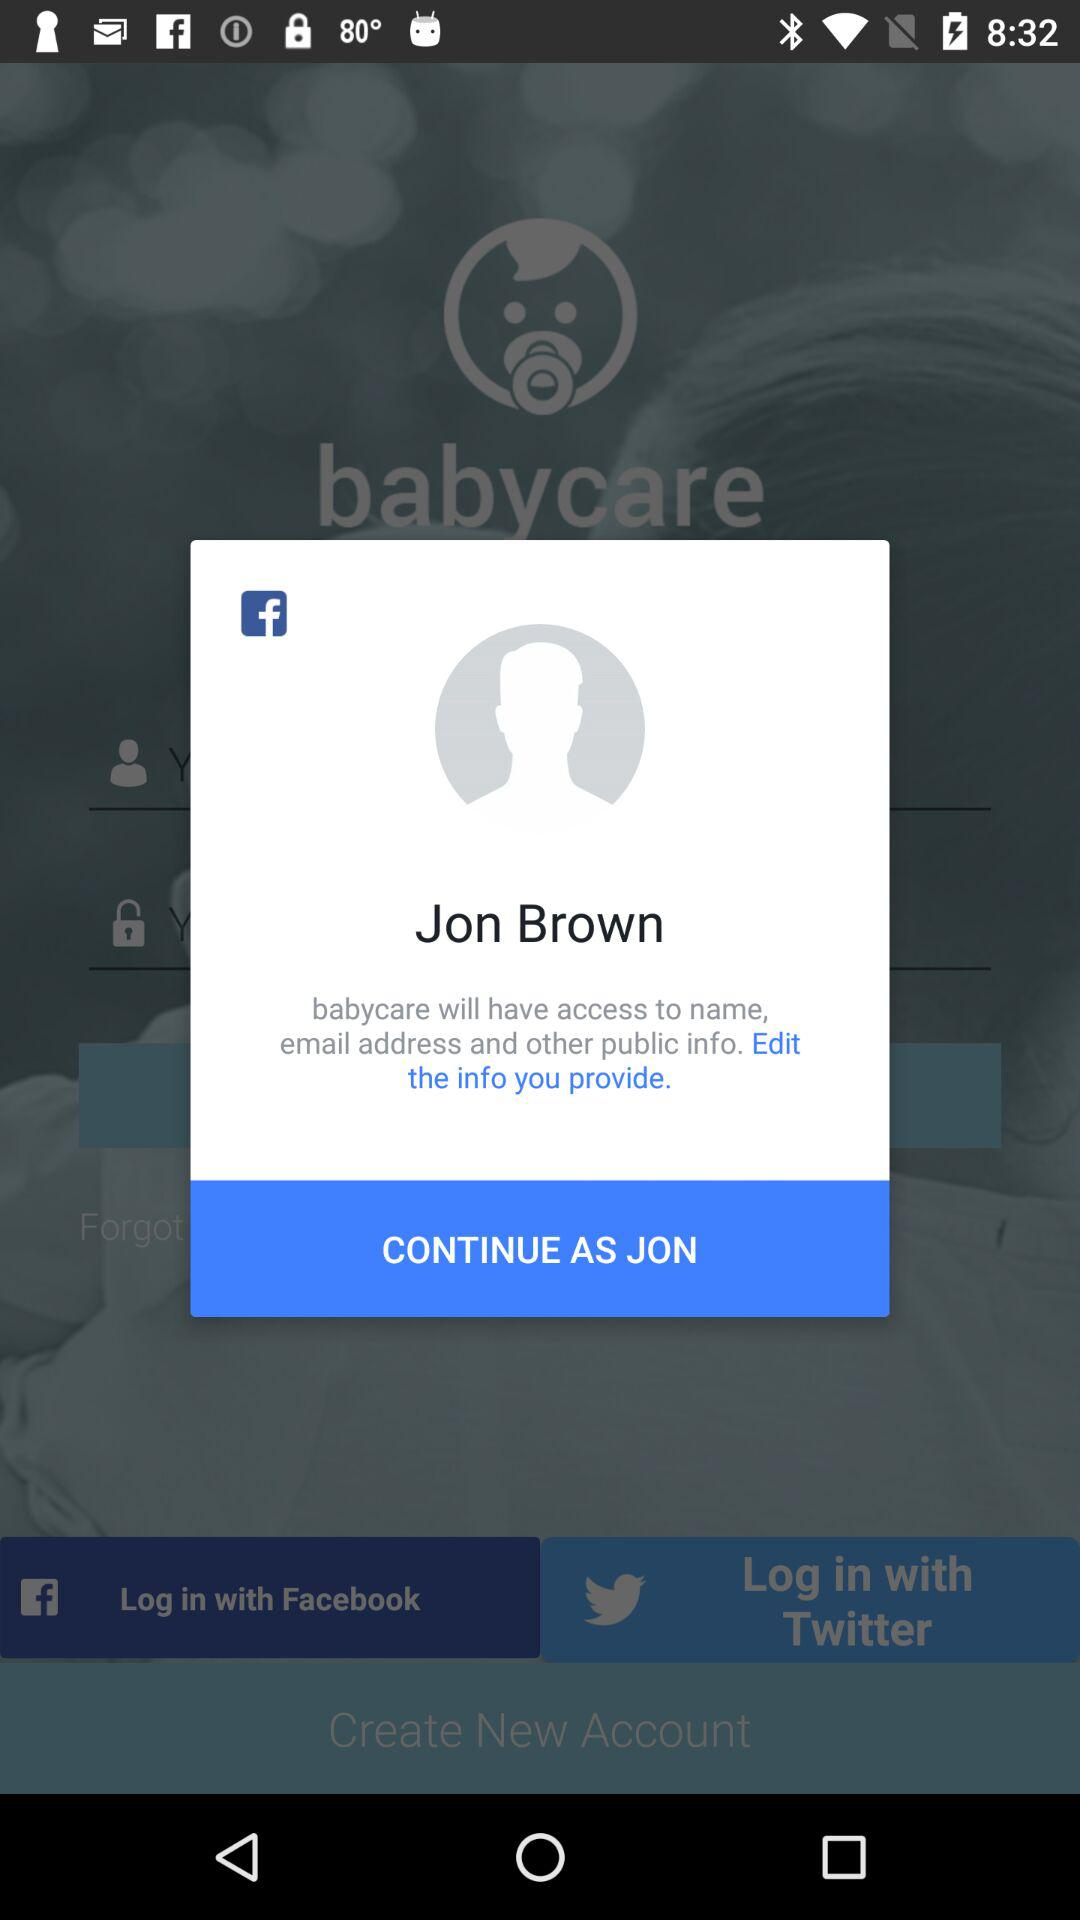What is the login name? The login name is Jon Brown. 